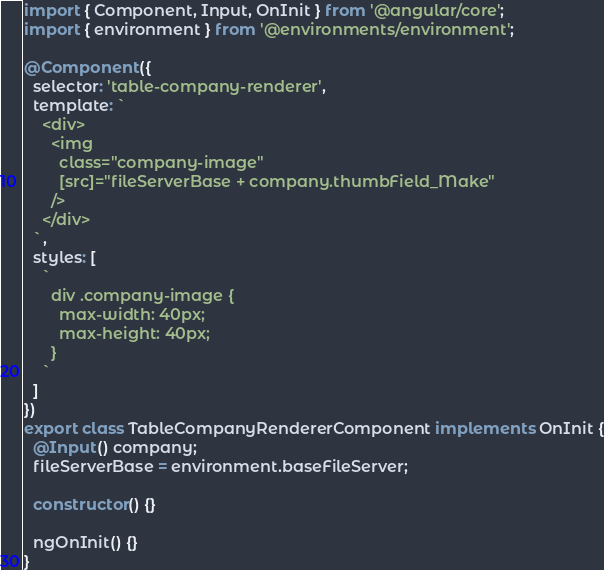<code> <loc_0><loc_0><loc_500><loc_500><_TypeScript_>import { Component, Input, OnInit } from '@angular/core';
import { environment } from '@environments/environment';

@Component({
  selector: 'table-company-renderer',
  template: `
    <div>
      <img
        class="company-image"
        [src]="fileServerBase + company.thumbField_Make"
      />
    </div>
  `,
  styles: [
    `
      div .company-image {
        max-width: 40px;
        max-height: 40px;
      }
    `
  ]
})
export class TableCompanyRendererComponent implements OnInit {
  @Input() company;
  fileServerBase = environment.baseFileServer;

  constructor() {}

  ngOnInit() {}
}
</code> 